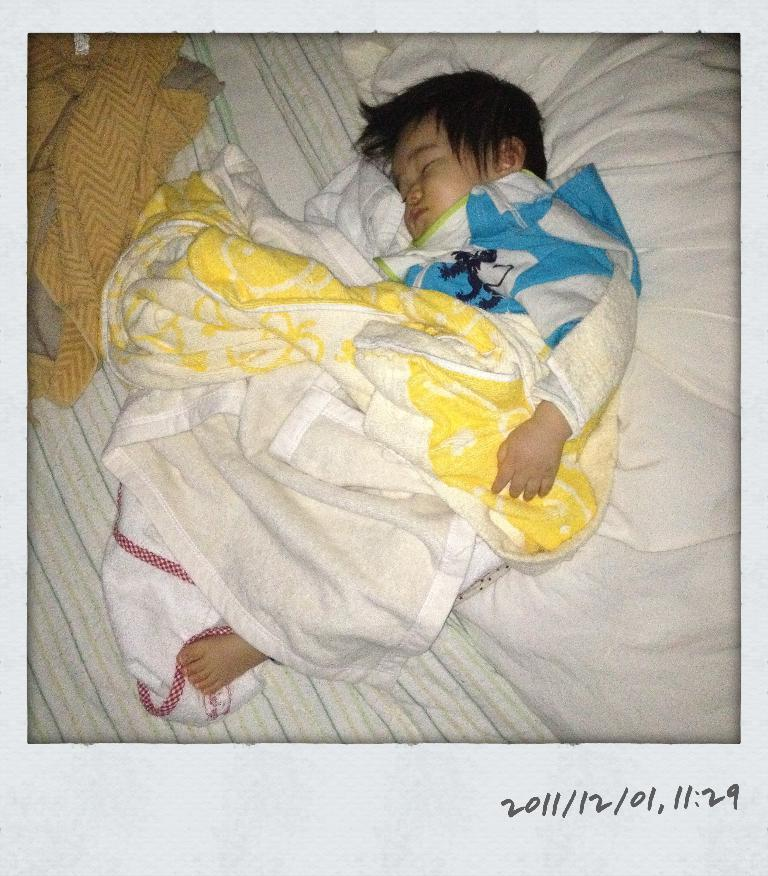What is the main subject of the image? There is a baby sleeping in the middle of the image. What else can be seen in the image besides the baby? There are clothes visible in the image. Where is the text located in the image? The text is in the bottom right-hand side of the image. How many ladybugs are crawling on the baby in the image? There are no ladybugs present in the image; the baby is sleeping peacefully. 